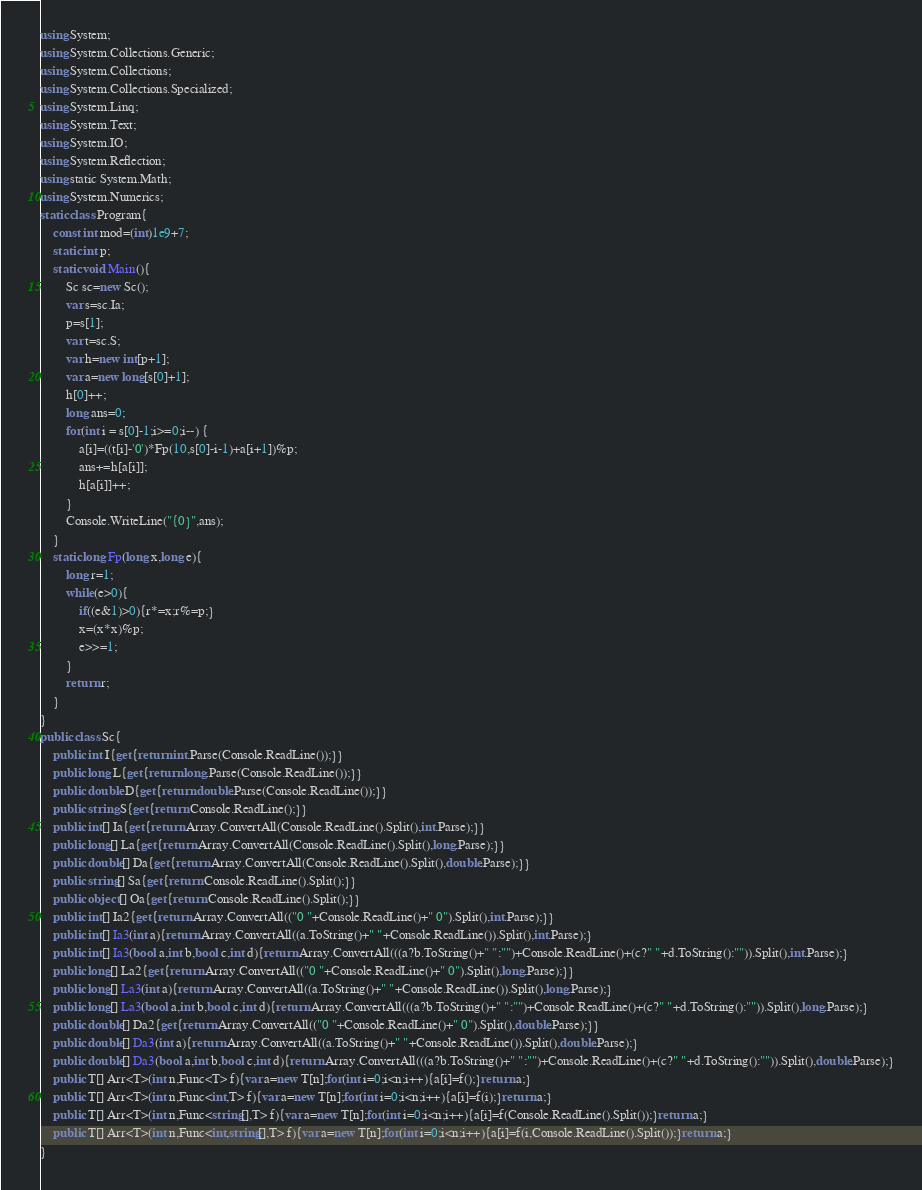Convert code to text. <code><loc_0><loc_0><loc_500><loc_500><_C#_>using System;
using System.Collections.Generic;
using System.Collections;
using System.Collections.Specialized;
using System.Linq;
using System.Text;
using System.IO;
using System.Reflection;
using static System.Math;
using System.Numerics;
static class Program{
	const int mod=(int)1e9+7;
	static int p;
	static void Main(){
		Sc sc=new Sc();
		var s=sc.Ia;
		p=s[1];
		var t=sc.S;
		var h=new int[p+1];
		var a=new long[s[0]+1];
		h[0]++;
		long ans=0;
		for(int i = s[0]-1;i>=0;i--) {
			a[i]=((t[i]-'0')*Fp(10,s[0]-i-1)+a[i+1])%p;
			ans+=h[a[i]];
			h[a[i]]++;
		}
		Console.WriteLine("{0}",ans);
	}
	static long Fp(long x,long e){
		long r=1;
		while(e>0){
			if((e&1)>0){r*=x;r%=p;}
			x=(x*x)%p;
			e>>=1;
		}
		return r;
	}
}
public class Sc{
	public int I{get{return int.Parse(Console.ReadLine());}}
	public long L{get{return long.Parse(Console.ReadLine());}}
	public double D{get{return double.Parse(Console.ReadLine());}}
	public string S{get{return Console.ReadLine();}}
	public int[] Ia{get{return Array.ConvertAll(Console.ReadLine().Split(),int.Parse);}}
	public long[] La{get{return Array.ConvertAll(Console.ReadLine().Split(),long.Parse);}}
	public double[] Da{get{return Array.ConvertAll(Console.ReadLine().Split(),double.Parse);}}
	public string[] Sa{get{return Console.ReadLine().Split();}}
	public object[] Oa{get{return Console.ReadLine().Split();}}
	public int[] Ia2{get{return Array.ConvertAll(("0 "+Console.ReadLine()+" 0").Split(),int.Parse);}}
	public int[] Ia3(int a){return Array.ConvertAll((a.ToString()+" "+Console.ReadLine()).Split(),int.Parse);}
	public int[] Ia3(bool a,int b,bool c,int d){return Array.ConvertAll(((a?b.ToString()+" ":"")+Console.ReadLine()+(c?" "+d.ToString():"")).Split(),int.Parse);}
	public long[] La2{get{return Array.ConvertAll(("0 "+Console.ReadLine()+" 0").Split(),long.Parse);}}
	public long[] La3(int a){return Array.ConvertAll((a.ToString()+" "+Console.ReadLine()).Split(),long.Parse);}
	public long[] La3(bool a,int b,bool c,int d){return Array.ConvertAll(((a?b.ToString()+" ":"")+Console.ReadLine()+(c?" "+d.ToString():"")).Split(),long.Parse);}
	public double[] Da2{get{return Array.ConvertAll(("0 "+Console.ReadLine()+" 0").Split(),double.Parse);}}
	public double[] Da3(int a){return Array.ConvertAll((a.ToString()+" "+Console.ReadLine()).Split(),double.Parse);}
	public double[] Da3(bool a,int b,bool c,int d){return Array.ConvertAll(((a?b.ToString()+" ":"")+Console.ReadLine()+(c?" "+d.ToString():"")).Split(),double.Parse);}
	public T[] Arr<T>(int n,Func<T> f){var a=new T[n];for(int i=0;i<n;i++){a[i]=f();}return a;}
	public T[] Arr<T>(int n,Func<int,T> f){var a=new T[n];for(int i=0;i<n;i++){a[i]=f(i);}return a;}
	public T[] Arr<T>(int n,Func<string[],T> f){var a=new T[n];for(int i=0;i<n;i++){a[i]=f(Console.ReadLine().Split());}return a;}
	public T[] Arr<T>(int n,Func<int,string[],T> f){var a=new T[n];for(int i=0;i<n;i++){a[i]=f(i,Console.ReadLine().Split());}return a;}
}</code> 